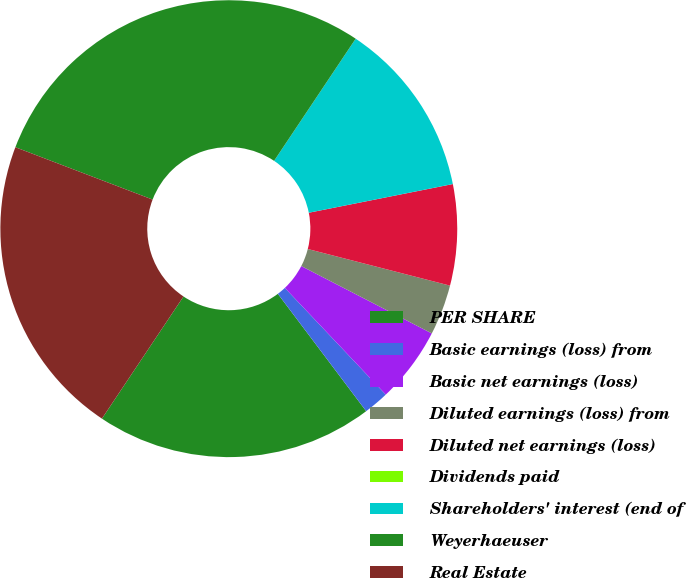<chart> <loc_0><loc_0><loc_500><loc_500><pie_chart><fcel>PER SHARE<fcel>Basic earnings (loss) from<fcel>Basic net earnings (loss)<fcel>Diluted earnings (loss) from<fcel>Diluted net earnings (loss)<fcel>Dividends paid<fcel>Shareholders' interest (end of<fcel>Weyerhaeuser<fcel>Real Estate<nl><fcel>19.64%<fcel>1.79%<fcel>5.36%<fcel>3.57%<fcel>7.14%<fcel>0.0%<fcel>12.5%<fcel>28.57%<fcel>21.43%<nl></chart> 